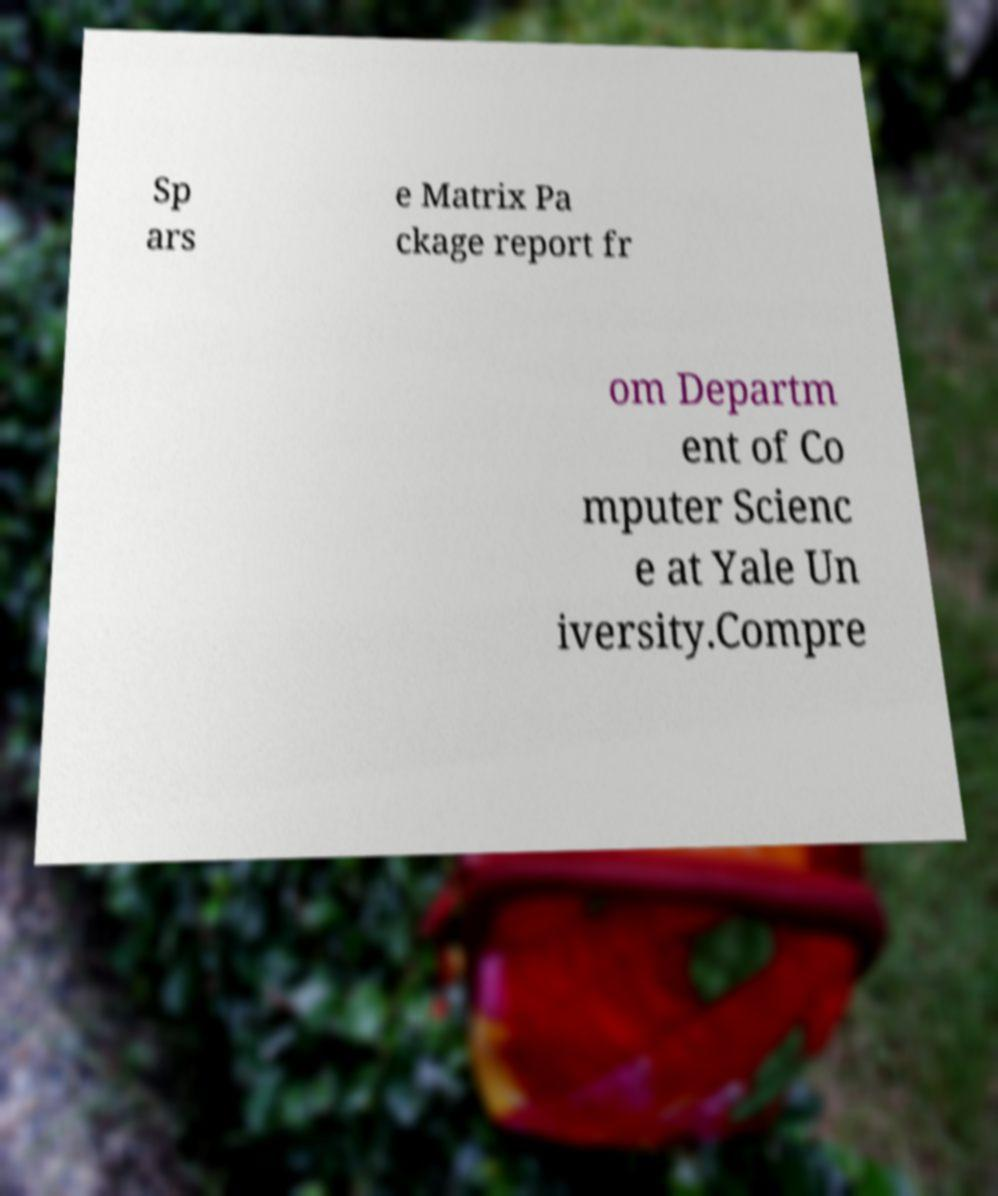Please read and relay the text visible in this image. What does it say? Sp ars e Matrix Pa ckage report fr om Departm ent of Co mputer Scienc e at Yale Un iversity.Compre 